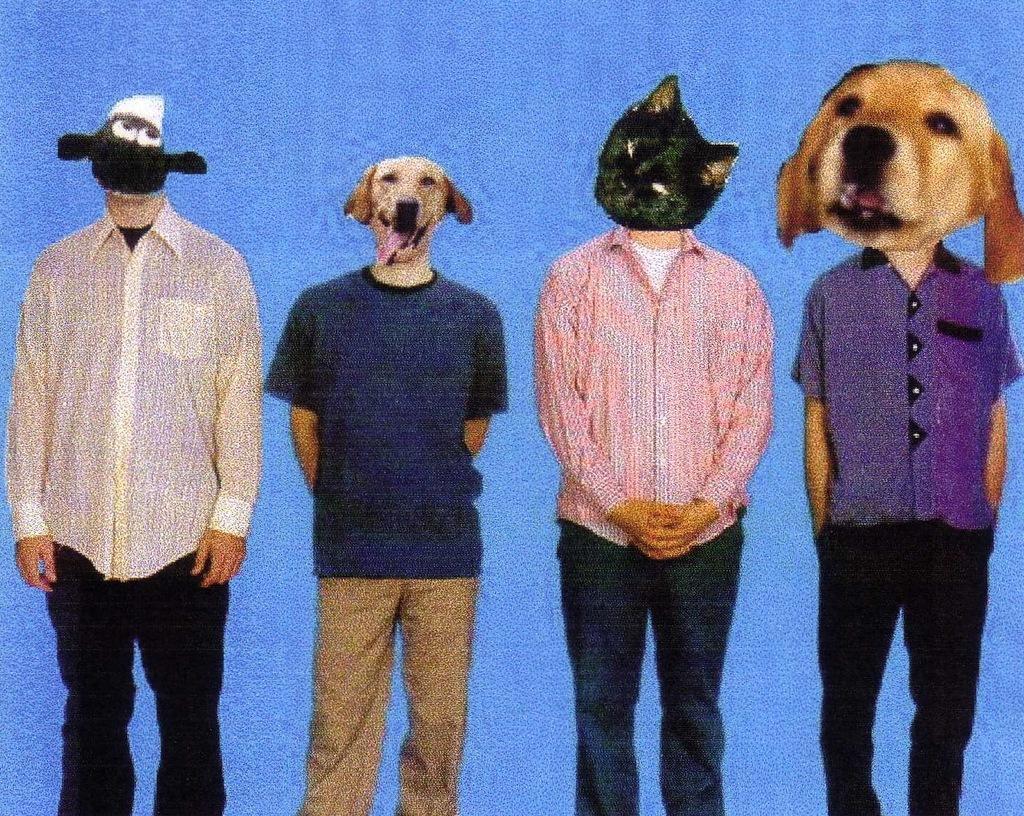How would you summarize this image in a sentence or two? This is an edited image. In this picture, we see four men are standing. The faces of the men are edited with the heads of cat and dog. In the background, it is blue in color. 